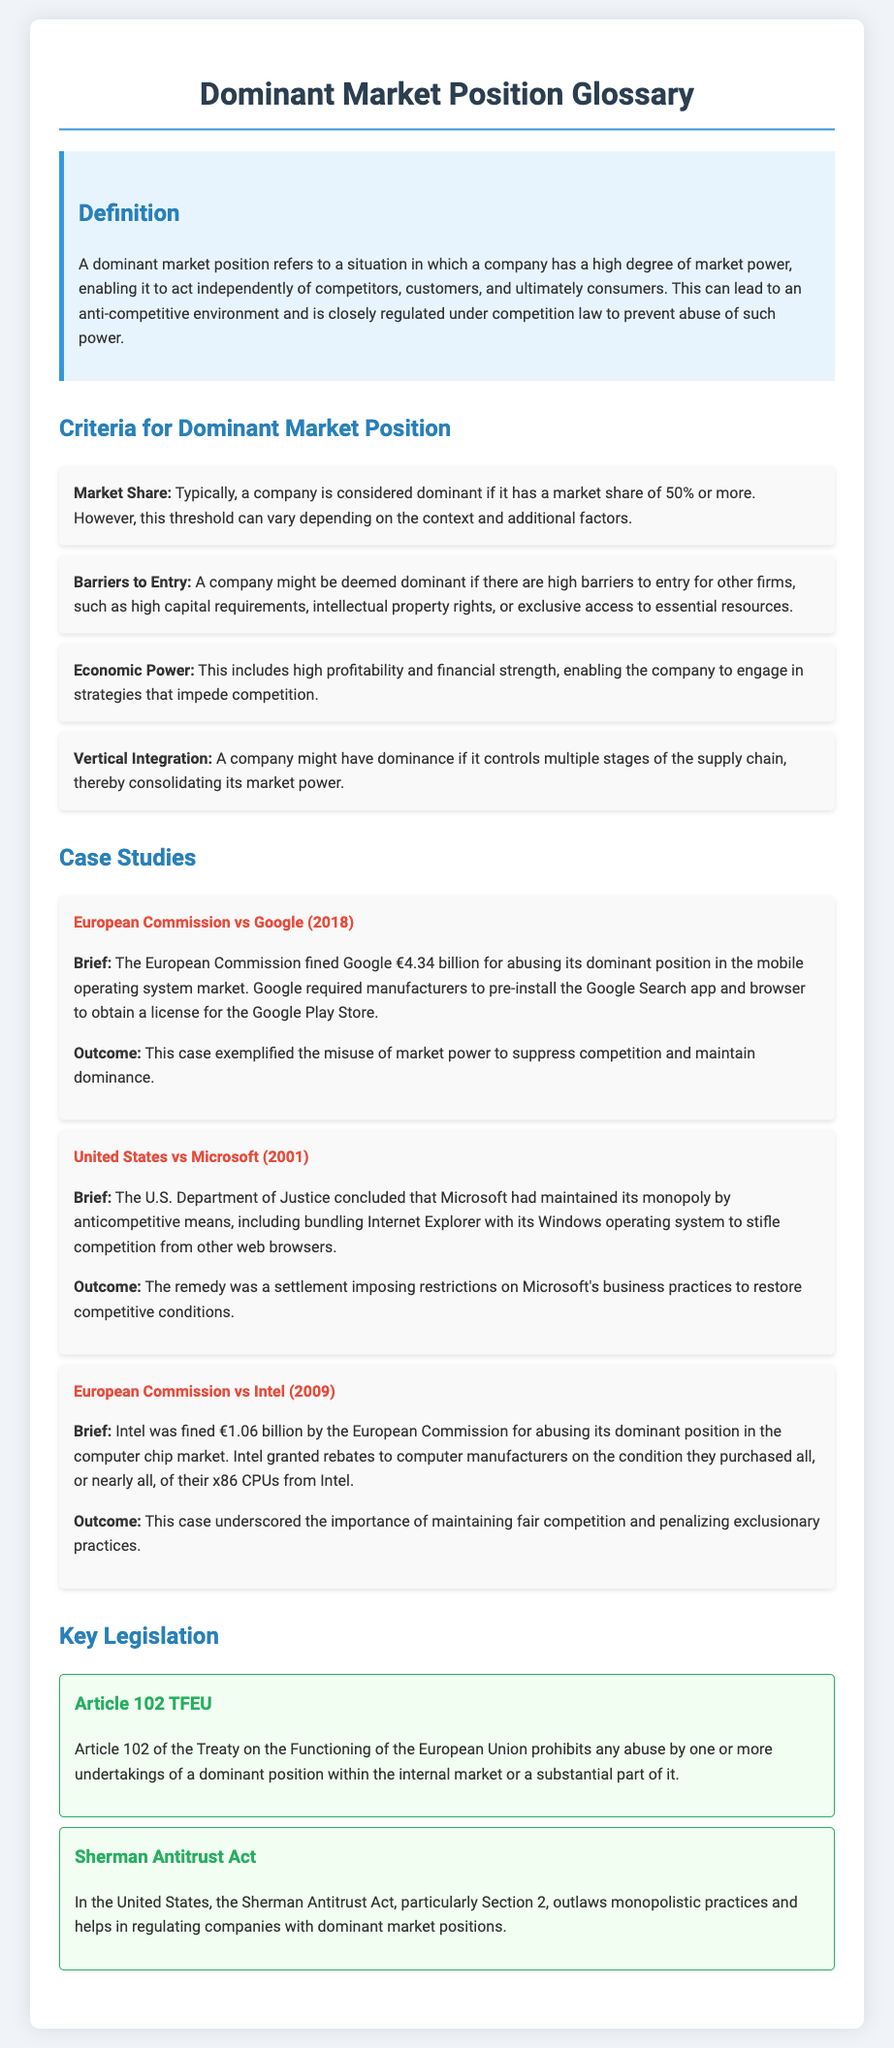What is a dominant market position? A dominant market position is defined in the document as a situation in which a company has a high degree of market power, enabling it to act independently of competitors, customers, and ultimately consumers.
Answer: A situation in which a company has a high degree of market power What market share percentage typically indicates dominance? The document states that a company is considered dominant if it has a market share of 50% or more.
Answer: 50% Which case involved the European Commission fining Google? The document mentions "European Commission vs Google (2018)" as the case where Google was fined.
Answer: European Commission vs Google (2018) What legislation prohibits abuse of dominant position within the EU? Article 102 TFEU is referenced in the document as prohibiting any abuse by undertakings of a dominant position.
Answer: Article 102 TFEU What were the conditions under which Intel granted rebates? The document describes that Intel granted rebates on the condition they purchased all, or nearly all, of their x86 CPUs from Intel.
Answer: Purchased all, or nearly all, of their x86 CPUs from Intel Which act outlaws monopolistic practices in the United States? The Sherman Antitrust Act is highlighted in the document as the act that outlaws monopolistic practices.
Answer: Sherman Antitrust Act What type of economic power is included in the criteria for dominance? The document specifies that high profitability and financial strength are included in the criteria for economic power.
Answer: High profitability and financial strength What was the outcome of the United States vs Microsoft case? The document states that the remedy was a settlement imposing restrictions on Microsoft's business practices.
Answer: A settlement imposing restrictions on Microsoft's business practices 